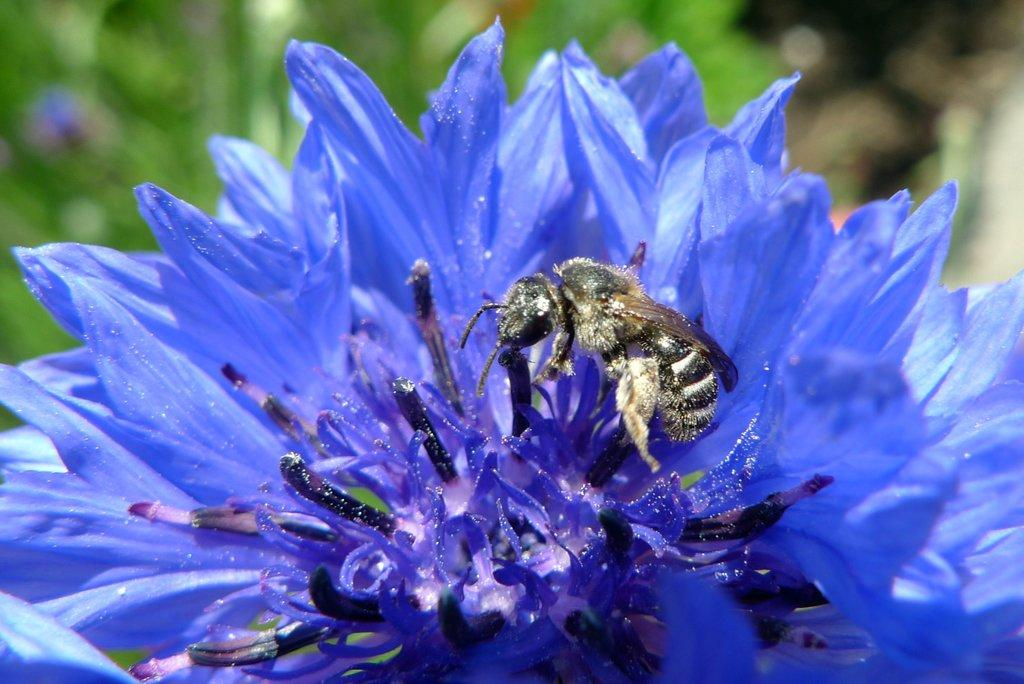What type of flower can be seen in the image? There is a purple flower in the image. Is there any other living organism interacting with the flower? Yes, a honey bee is sitting on the flower. What can be observed in the background of the image? The background of the image is green and blurred. Where is the mitten located in the image? There is no mitten present in the image. Can you describe the squirrel's behavior in the image? There is no squirrel present in the image. 